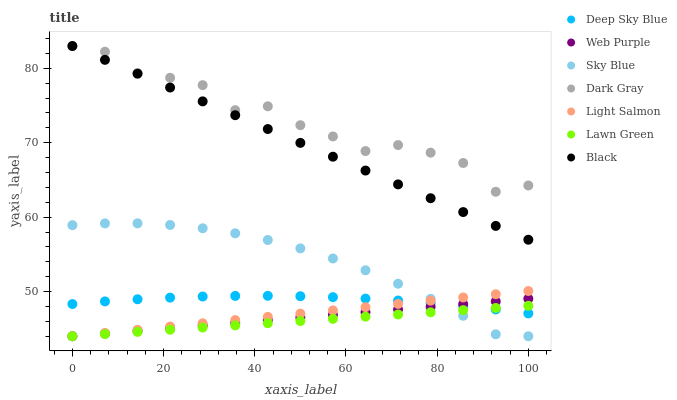Does Lawn Green have the minimum area under the curve?
Answer yes or no. Yes. Does Dark Gray have the maximum area under the curve?
Answer yes or no. Yes. Does Light Salmon have the minimum area under the curve?
Answer yes or no. No. Does Light Salmon have the maximum area under the curve?
Answer yes or no. No. Is Lawn Green the smoothest?
Answer yes or no. Yes. Is Dark Gray the roughest?
Answer yes or no. Yes. Is Light Salmon the smoothest?
Answer yes or no. No. Is Light Salmon the roughest?
Answer yes or no. No. Does Lawn Green have the lowest value?
Answer yes or no. Yes. Does Dark Gray have the lowest value?
Answer yes or no. No. Does Black have the highest value?
Answer yes or no. Yes. Does Light Salmon have the highest value?
Answer yes or no. No. Is Sky Blue less than Black?
Answer yes or no. Yes. Is Dark Gray greater than Lawn Green?
Answer yes or no. Yes. Does Sky Blue intersect Light Salmon?
Answer yes or no. Yes. Is Sky Blue less than Light Salmon?
Answer yes or no. No. Is Sky Blue greater than Light Salmon?
Answer yes or no. No. Does Sky Blue intersect Black?
Answer yes or no. No. 